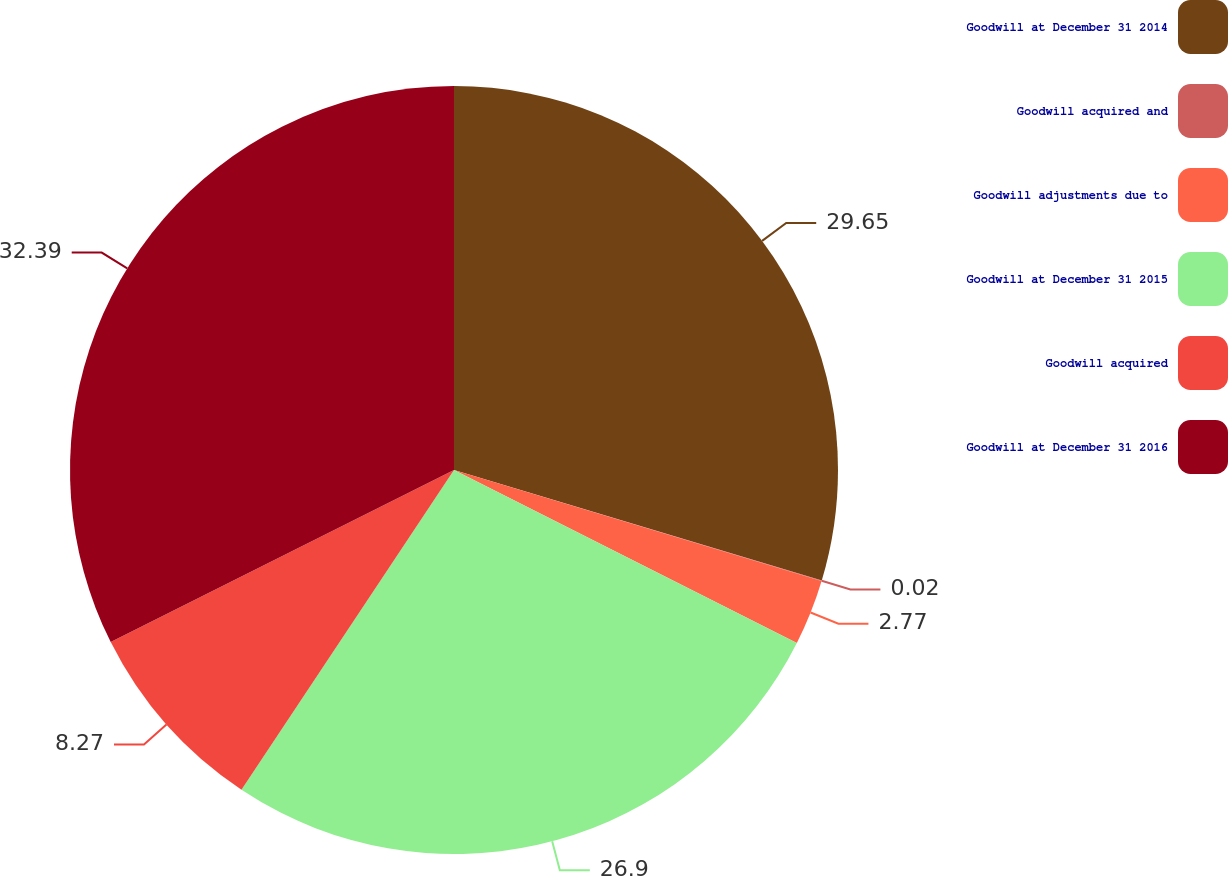Convert chart. <chart><loc_0><loc_0><loc_500><loc_500><pie_chart><fcel>Goodwill at December 31 2014<fcel>Goodwill acquired and<fcel>Goodwill adjustments due to<fcel>Goodwill at December 31 2015<fcel>Goodwill acquired<fcel>Goodwill at December 31 2016<nl><fcel>29.65%<fcel>0.02%<fcel>2.77%<fcel>26.9%<fcel>8.27%<fcel>32.4%<nl></chart> 